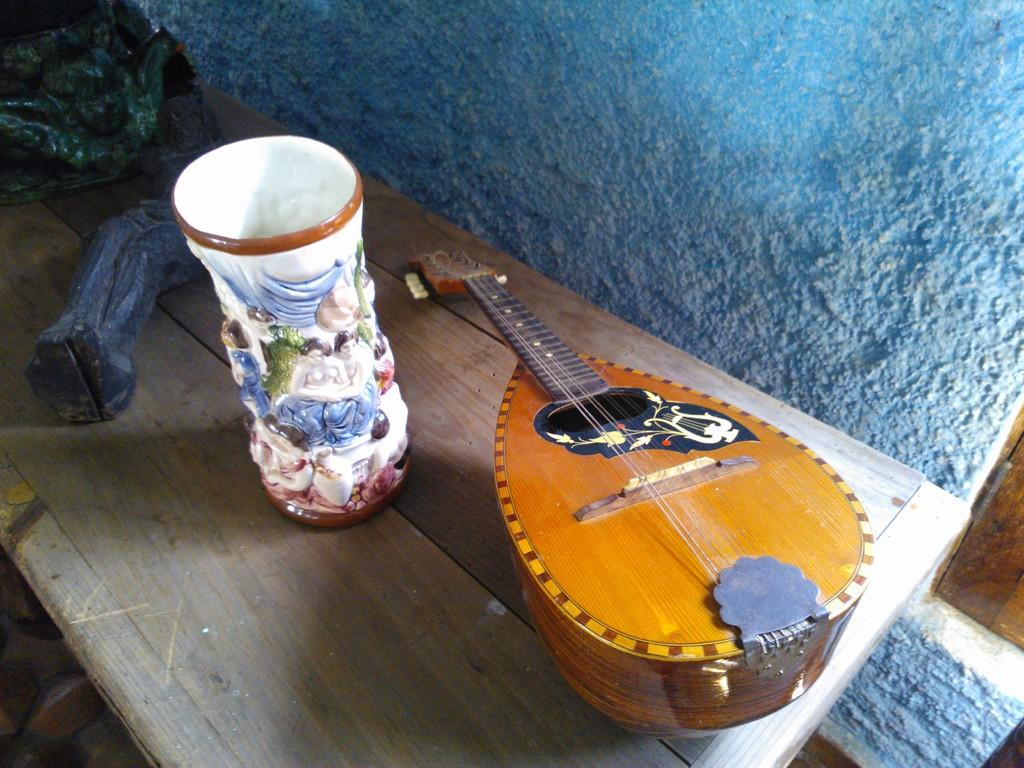What is placed on the table in the image? There is a flower vase and a sitar on the table. What color is the wall in the background of the image? The wall in the background of the image is blue. What type of chain is wrapped around the wrist of the sitar player in the image? There is no sitar player present in the image, and therefore no wrist or chain can be observed. 